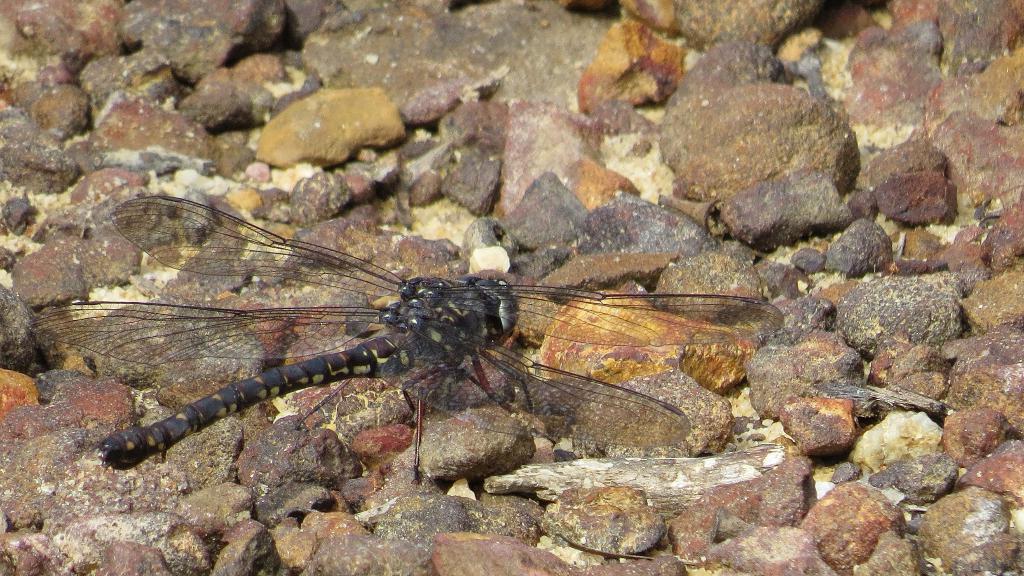Describe this image in one or two sentences. In this image in the center there is an insect and there are stones. 